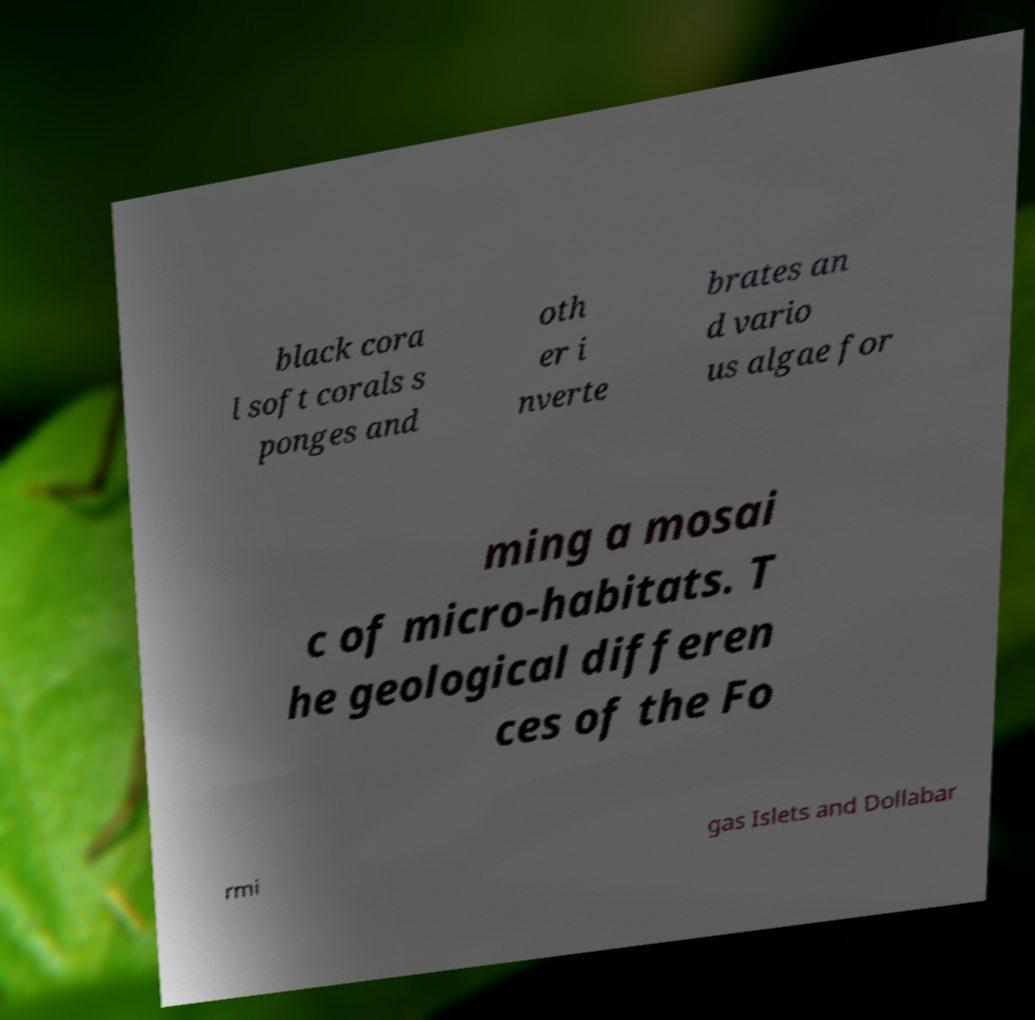I need the written content from this picture converted into text. Can you do that? black cora l soft corals s ponges and oth er i nverte brates an d vario us algae for ming a mosai c of micro-habitats. T he geological differen ces of the Fo rmi gas Islets and Dollabar 